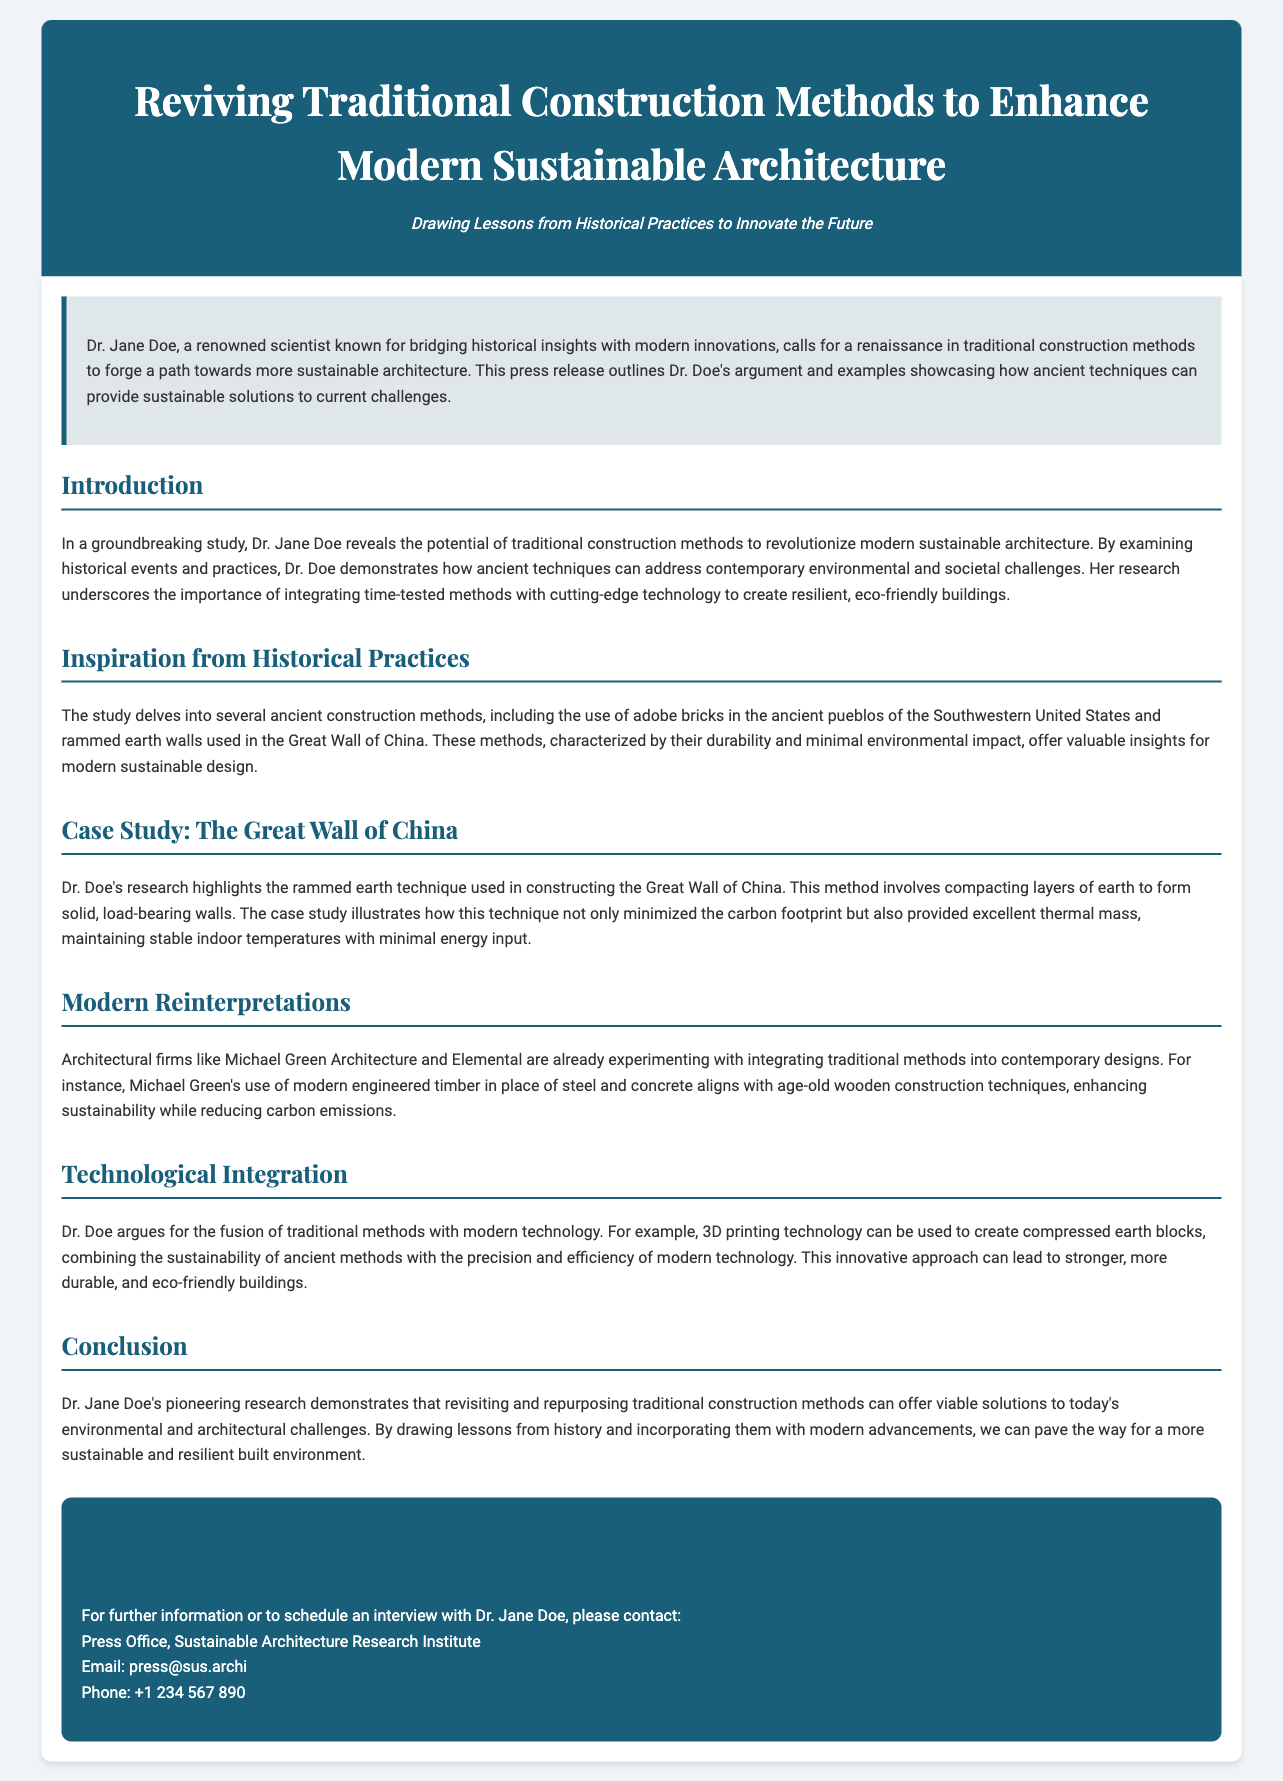What is the name of the scientist mentioned in the press release? The press release prominently mentions Dr. Jane Doe as the renowned scientist.
Answer: Dr. Jane Doe What construction technique is highlighted as part of the Great Wall of China case study? The press release specifies that the rammed earth technique is highlighted in the case study.
Answer: Rammed earth Which architectural firm is mentioned as experimenting with traditional methods? The document lists Michael Green Architecture as one of the firms experimenting with traditional methods in modern designs.
Answer: Michael Green Architecture What technology does Dr. Doe suggest integrating with traditional methods? The press release refers to 3D printing technology as a suggested integration with traditional construction methods.
Answer: 3D printing technology What is the email provided for contacting the press office? The document provides an email address for press inquiries to the Sustainable Architecture Research Institute.
Answer: press@sus.archi What is the main argument of Dr. Doe’s research? The press release states that Dr. Doe's research argues for the revival of traditional methods as solutions to modern challenges.
Answer: Reviving traditional methods How does Dr. Doe propose to minimize carbon footprints in modern architecture? The document indicates that using ancient techniques, such as rammed earth, helps minimize carbon footprints in construction.
Answer: Ancient techniques What type of buildings does the press release suggest can be created by combining traditional and modern methods? The press release suggests that stronger, more durable, and eco-friendly buildings can be created through the combination of these methods.
Answer: Stronger, eco-friendly buildings 